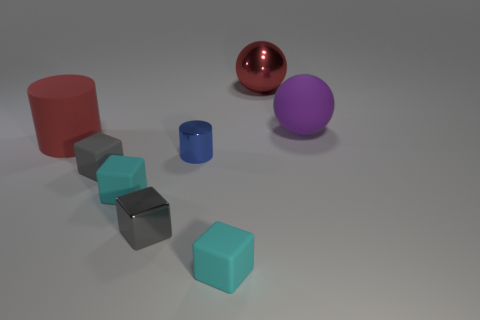Add 2 cyan matte spheres. How many objects exist? 10 Subtract all cylinders. How many objects are left? 6 Subtract 1 red spheres. How many objects are left? 7 Subtract all tiny gray objects. Subtract all red cylinders. How many objects are left? 5 Add 5 small blocks. How many small blocks are left? 9 Add 5 big gray metal blocks. How many big gray metal blocks exist? 5 